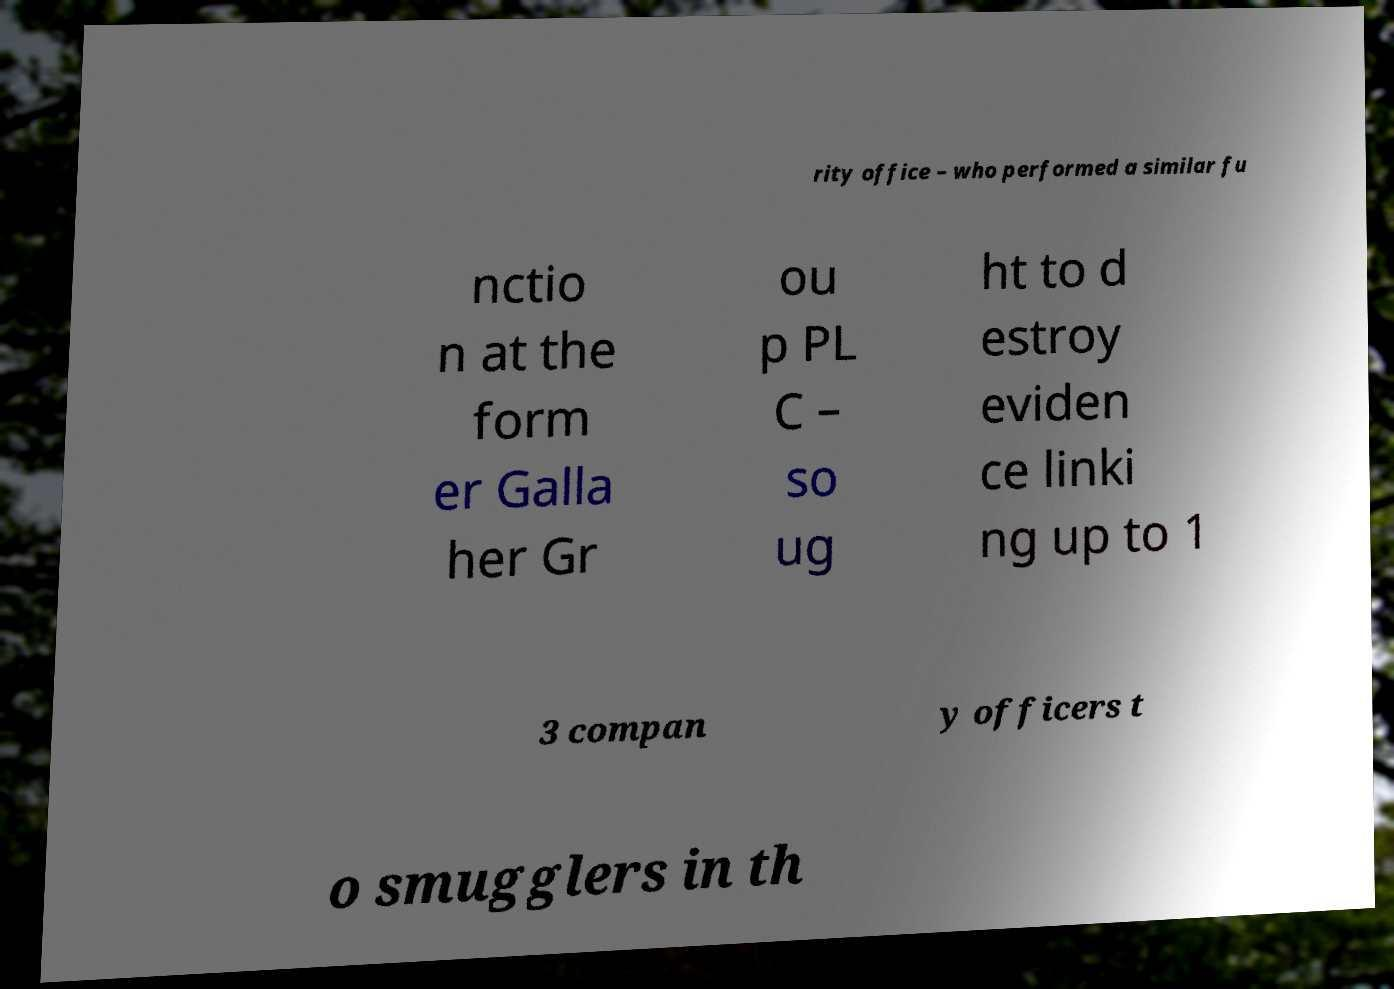Please read and relay the text visible in this image. What does it say? rity office – who performed a similar fu nctio n at the form er Galla her Gr ou p PL C – so ug ht to d estroy eviden ce linki ng up to 1 3 compan y officers t o smugglers in th 